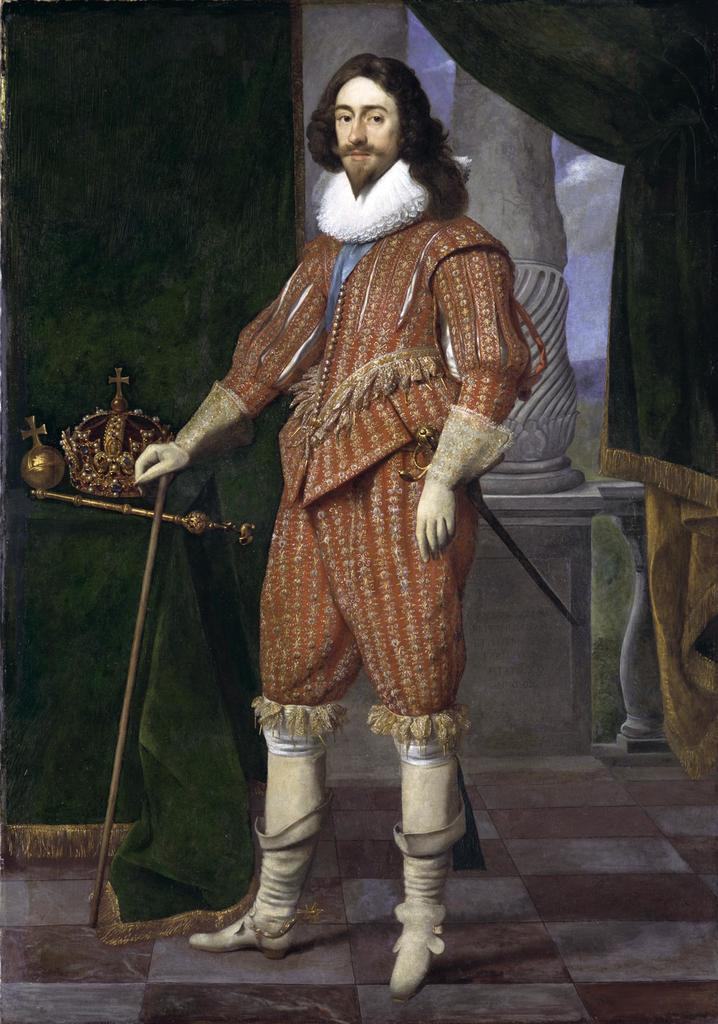What is depicted in the painting in the image? There is a painting of a person in the image. What is the person in the painting doing? The person in the painting is holding an object. What type of window treatment is present in the image? There are curtains in the image. Can you describe any other objects visible in the image? There are other unspecified objects in the image. What game is the person in the painting playing with their aunt in the image? There is no game or person's aunt present in the image; it only features a painting of a person holding an object. How does the person in the painting fall when they see the leaves changing colors in the image? There is no mention of leaves changing colors or the person falling in the image; it only shows a painting of a person holding an object. 